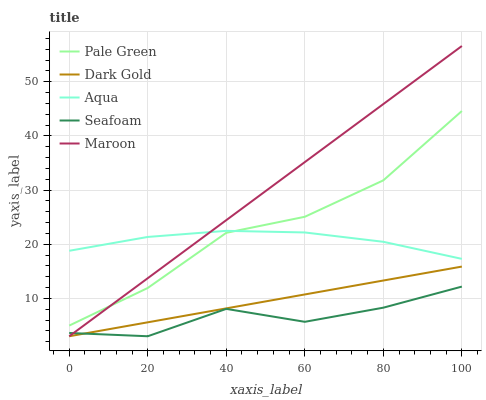Does Seafoam have the minimum area under the curve?
Answer yes or no. Yes. Does Maroon have the maximum area under the curve?
Answer yes or no. Yes. Does Aqua have the minimum area under the curve?
Answer yes or no. No. Does Aqua have the maximum area under the curve?
Answer yes or no. No. Is Dark Gold the smoothest?
Answer yes or no. Yes. Is Pale Green the roughest?
Answer yes or no. Yes. Is Aqua the smoothest?
Answer yes or no. No. Is Aqua the roughest?
Answer yes or no. No. Does Seafoam have the lowest value?
Answer yes or no. Yes. Does Aqua have the lowest value?
Answer yes or no. No. Does Maroon have the highest value?
Answer yes or no. Yes. Does Aqua have the highest value?
Answer yes or no. No. Is Seafoam less than Pale Green?
Answer yes or no. Yes. Is Aqua greater than Dark Gold?
Answer yes or no. Yes. Does Dark Gold intersect Seafoam?
Answer yes or no. Yes. Is Dark Gold less than Seafoam?
Answer yes or no. No. Is Dark Gold greater than Seafoam?
Answer yes or no. No. Does Seafoam intersect Pale Green?
Answer yes or no. No. 